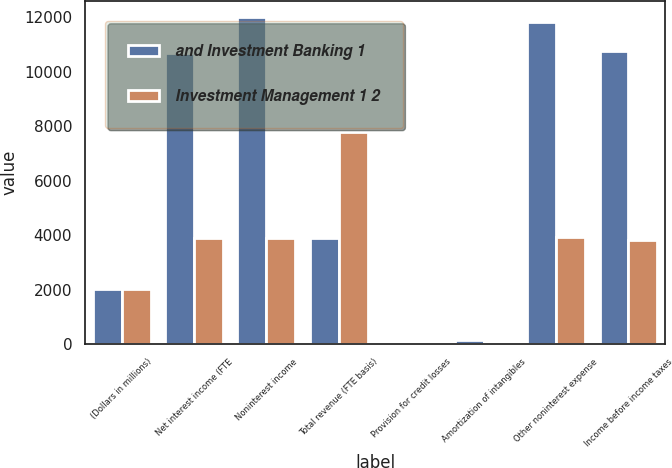<chart> <loc_0><loc_0><loc_500><loc_500><stacked_bar_chart><ecel><fcel>(Dollars in millions)<fcel>Net interest income (FTE<fcel>Noninterest income<fcel>Total revenue (FTE basis)<fcel>Provision for credit losses<fcel>Amortization of intangibles<fcel>Other noninterest expense<fcel>Income before income taxes<nl><fcel>and Investment Banking 1<fcel>2006<fcel>10693<fcel>11998<fcel>3881<fcel>6<fcel>164<fcel>11834<fcel>10752<nl><fcel>Investment Management 1 2<fcel>2006<fcel>3881<fcel>3898<fcel>7779<fcel>40<fcel>76<fcel>3929<fcel>3814<nl></chart> 